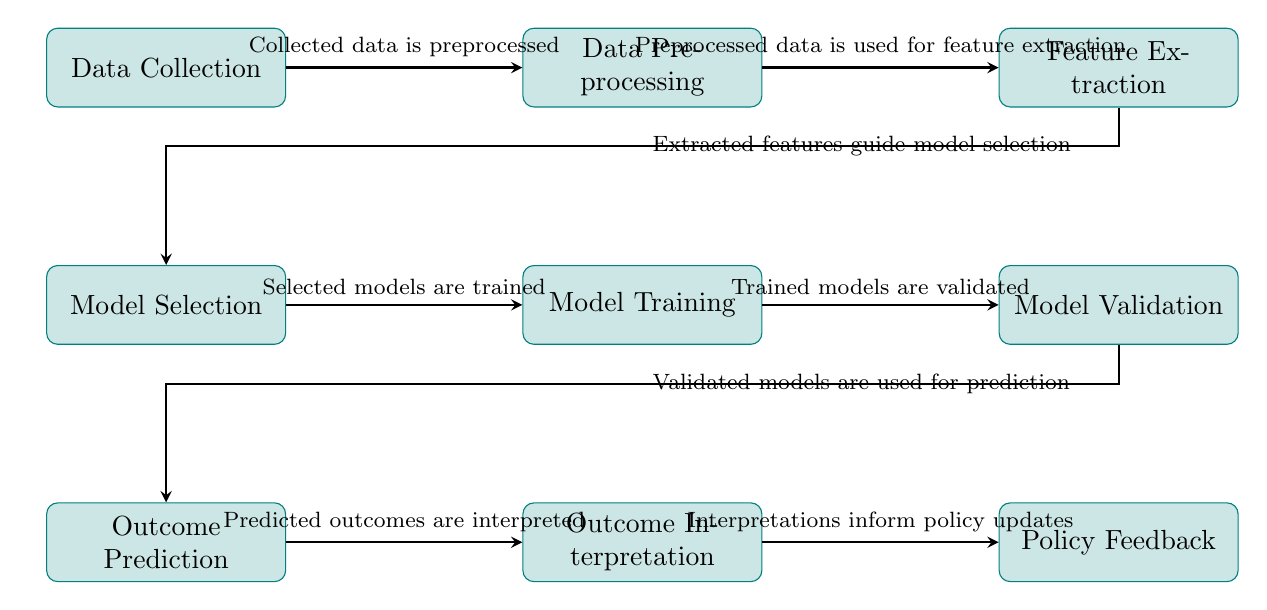What is the first step in the diagram? The first step is Data Collection, as indicated by the topmost node in the diagram.
Answer: Data Collection How many main processes are in the diagram? There are eight main processes represented as nodes in the diagram, counting from Data Collection to Policy Feedback.
Answer: Eight Which step follows Data Preprocessing? Feature Extraction immediately follows Data Preprocessing, as shown by the arrow connecting them in the diagram.
Answer: Feature Extraction What do the extracted features guide? The extracted features guide Model Selection, as stated by the label on the arrow connecting these two nodes.
Answer: Model Selection What happens after Model Validation? After Model Validation, the next step is Outcome Prediction, as indicated by the flow of the diagram to the subsequent node.
Answer: Outcome Prediction Which process directly informs policy updates? Outcome Interpretation is the process that directly informs Policy Feedback, as shown in the final arrow in the diagram.
Answer: Outcome Interpretation Describe the relationship between Model Training and Model Validation. Model Training is followed directly by Model Validation, meaning models that have been trained are subsequently validated according to the workflow indicated.
Answer: Model Training and Model Validation are sequential processes What connects the processes of Outcome Prediction and Outcome Interpretation? The connection is established by an arrow labeled "Predicted outcomes are interpreted," showing the flow of information from prediction to interpretation.
Answer: An arrow Which process comes before Policy Feedback? Policy Feedback is preceded by Outcome Interpretation, indicating the flow of information leading to policy decisions based on interpreted outcomes.
Answer: Outcome Interpretation 